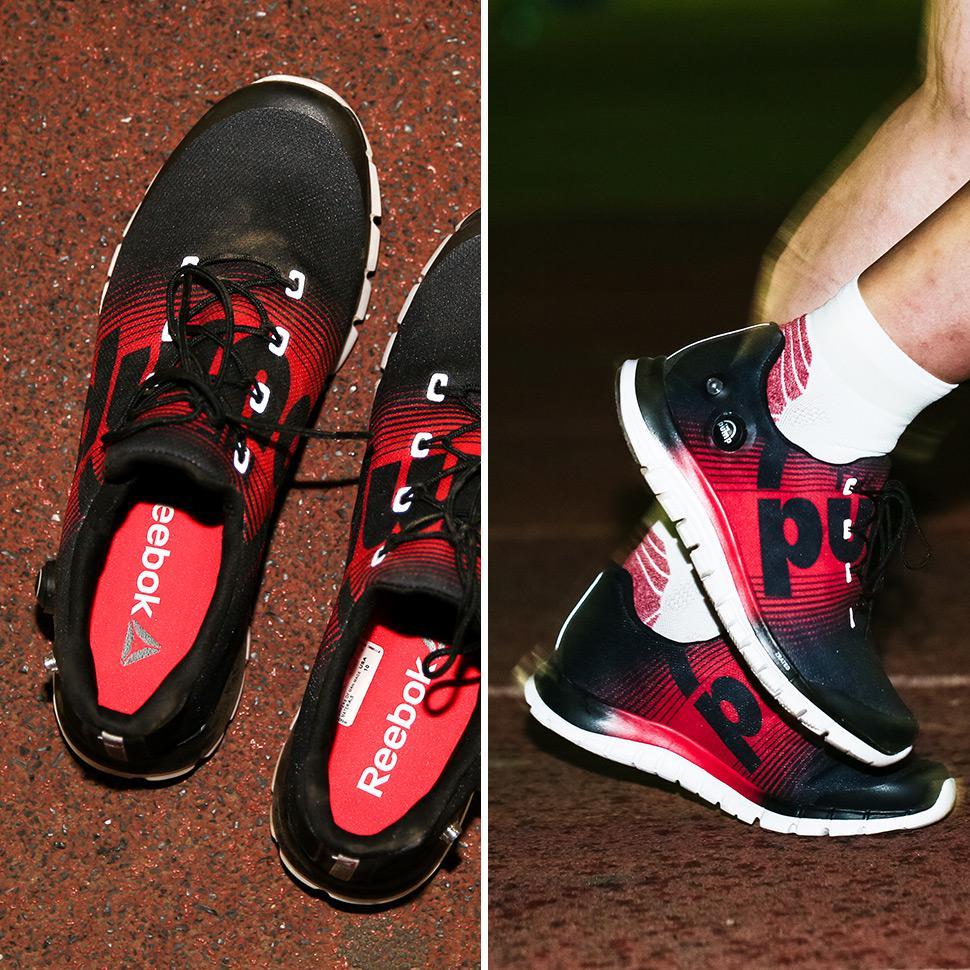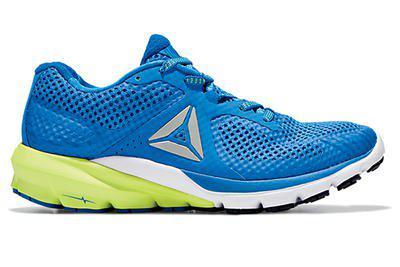The first image is the image on the left, the second image is the image on the right. Examine the images to the left and right. Is the description "The left image shows running shoes that are being worn on human feet" accurate? Answer yes or no. Yes. The first image is the image on the left, the second image is the image on the right. For the images shown, is this caption "An image contains only one right-side-up blue sneaker with a sole that is at least partly white." true? Answer yes or no. Yes. 